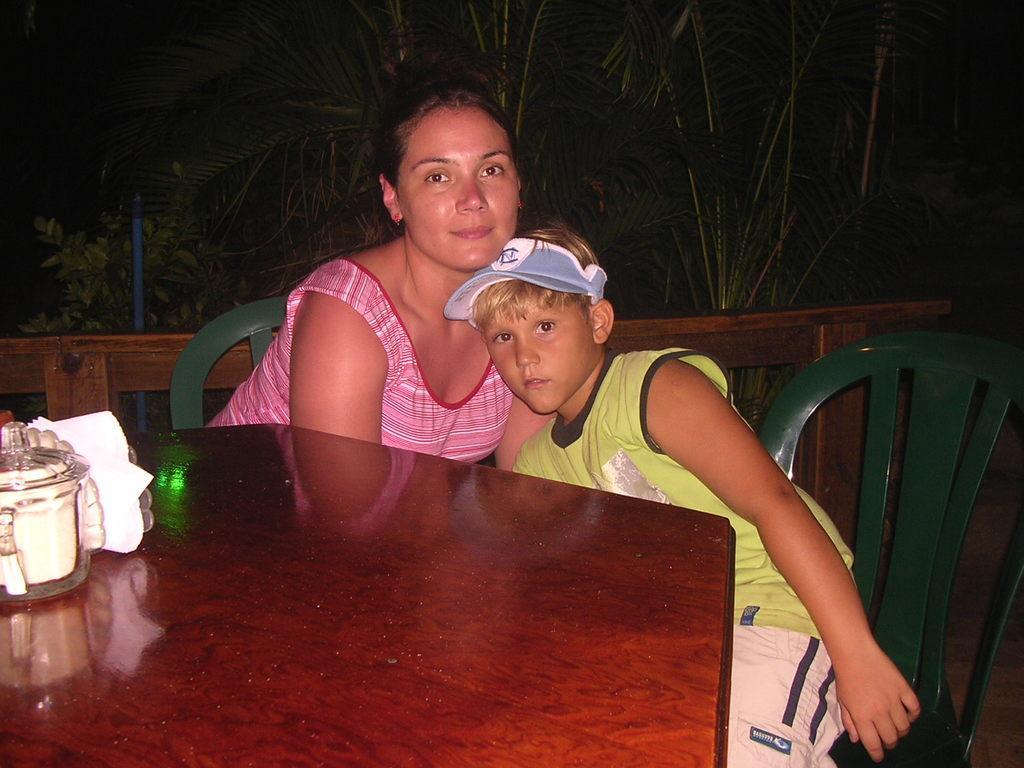Can you describe this image briefly? In the center of the image there are two people sitting on the chairs before them there is a table. We can see jars and napkins placed on the table. In the background there is a fence and trees. 